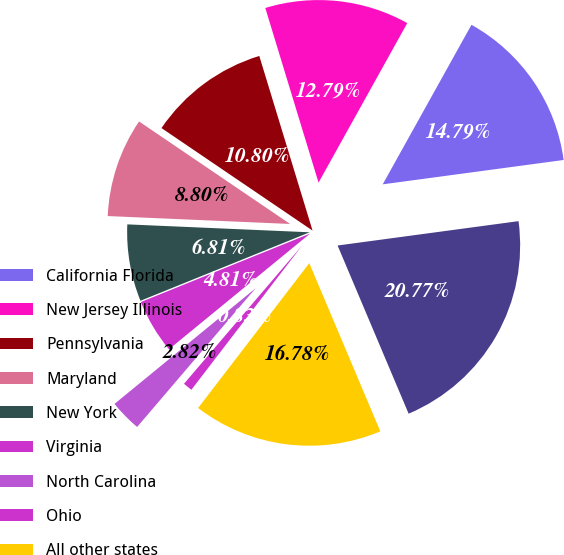Convert chart. <chart><loc_0><loc_0><loc_500><loc_500><pie_chart><fcel>California Florida<fcel>New Jersey Illinois<fcel>Pennsylvania<fcel>Maryland<fcel>New York<fcel>Virginia<fcel>North Carolina<fcel>Ohio<fcel>All other states<fcel>estate loans<nl><fcel>14.79%<fcel>12.79%<fcel>10.8%<fcel>8.8%<fcel>6.81%<fcel>4.81%<fcel>2.82%<fcel>0.83%<fcel>16.78%<fcel>20.77%<nl></chart> 